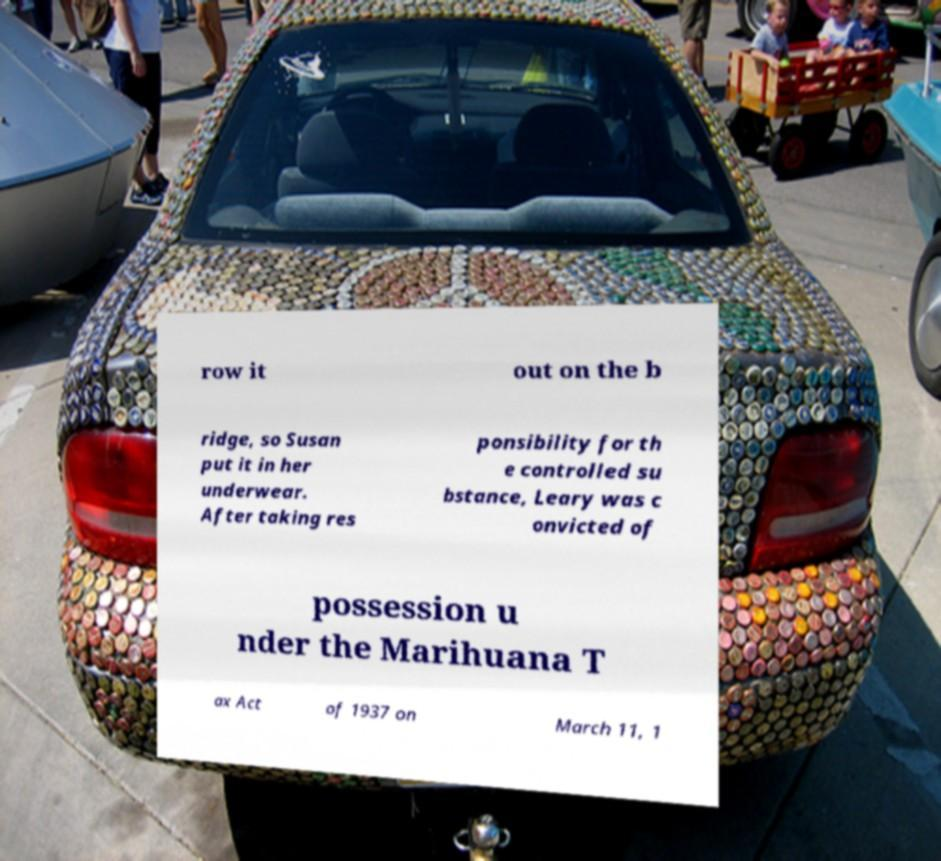Could you extract and type out the text from this image? row it out on the b ridge, so Susan put it in her underwear. After taking res ponsibility for th e controlled su bstance, Leary was c onvicted of possession u nder the Marihuana T ax Act of 1937 on March 11, 1 